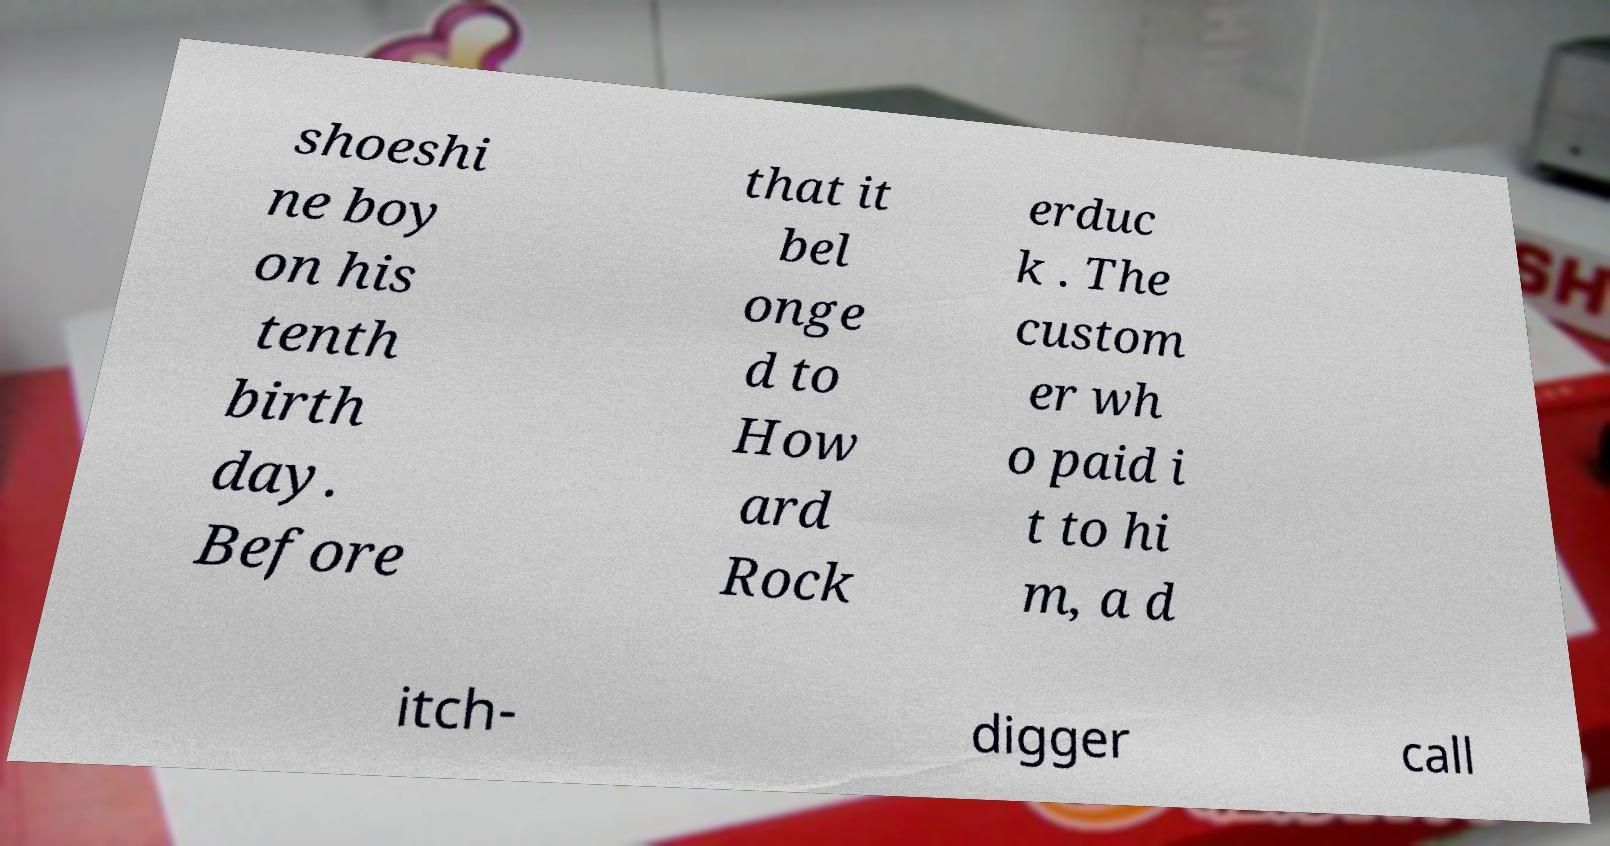Can you accurately transcribe the text from the provided image for me? shoeshi ne boy on his tenth birth day. Before that it bel onge d to How ard Rock erduc k . The custom er wh o paid i t to hi m, a d itch- digger call 